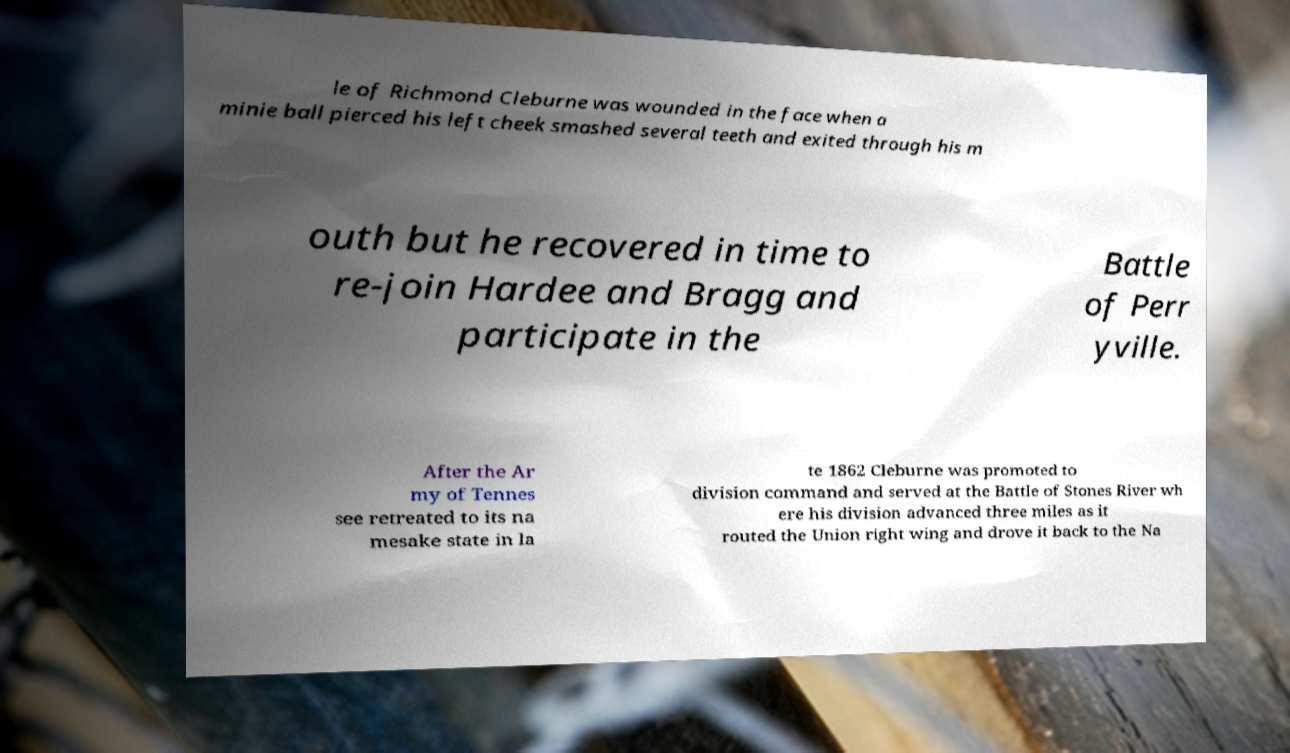Can you accurately transcribe the text from the provided image for me? le of Richmond Cleburne was wounded in the face when a minie ball pierced his left cheek smashed several teeth and exited through his m outh but he recovered in time to re-join Hardee and Bragg and participate in the Battle of Perr yville. After the Ar my of Tennes see retreated to its na mesake state in la te 1862 Cleburne was promoted to division command and served at the Battle of Stones River wh ere his division advanced three miles as it routed the Union right wing and drove it back to the Na 